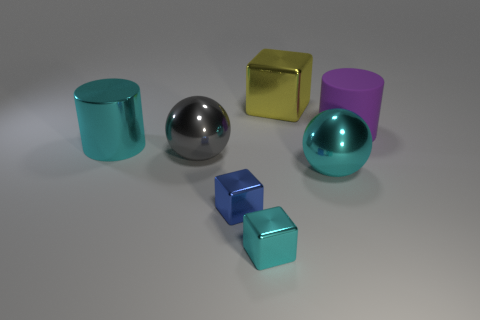How many other objects are the same shape as the large gray thing?
Your answer should be very brief. 1. What color is the matte cylinder that is the same size as the yellow shiny cube?
Your response must be concise. Purple. There is a metallic cube that is behind the rubber object; does it have the same size as the large purple thing?
Keep it short and to the point. Yes. Does the rubber cylinder have the same color as the big shiny cube?
Offer a terse response. No. How many balls are there?
Your answer should be very brief. 2. What number of spheres are either big things or tiny blue objects?
Your answer should be compact. 2. How many gray spheres are to the right of the gray metallic ball that is to the left of the rubber thing?
Ensure brevity in your answer.  0. Is the large cyan cylinder made of the same material as the blue thing?
Provide a short and direct response. Yes. The sphere that is the same color as the big metal cylinder is what size?
Your answer should be compact. Large. Is there a big cyan cylinder made of the same material as the big purple thing?
Ensure brevity in your answer.  No. 